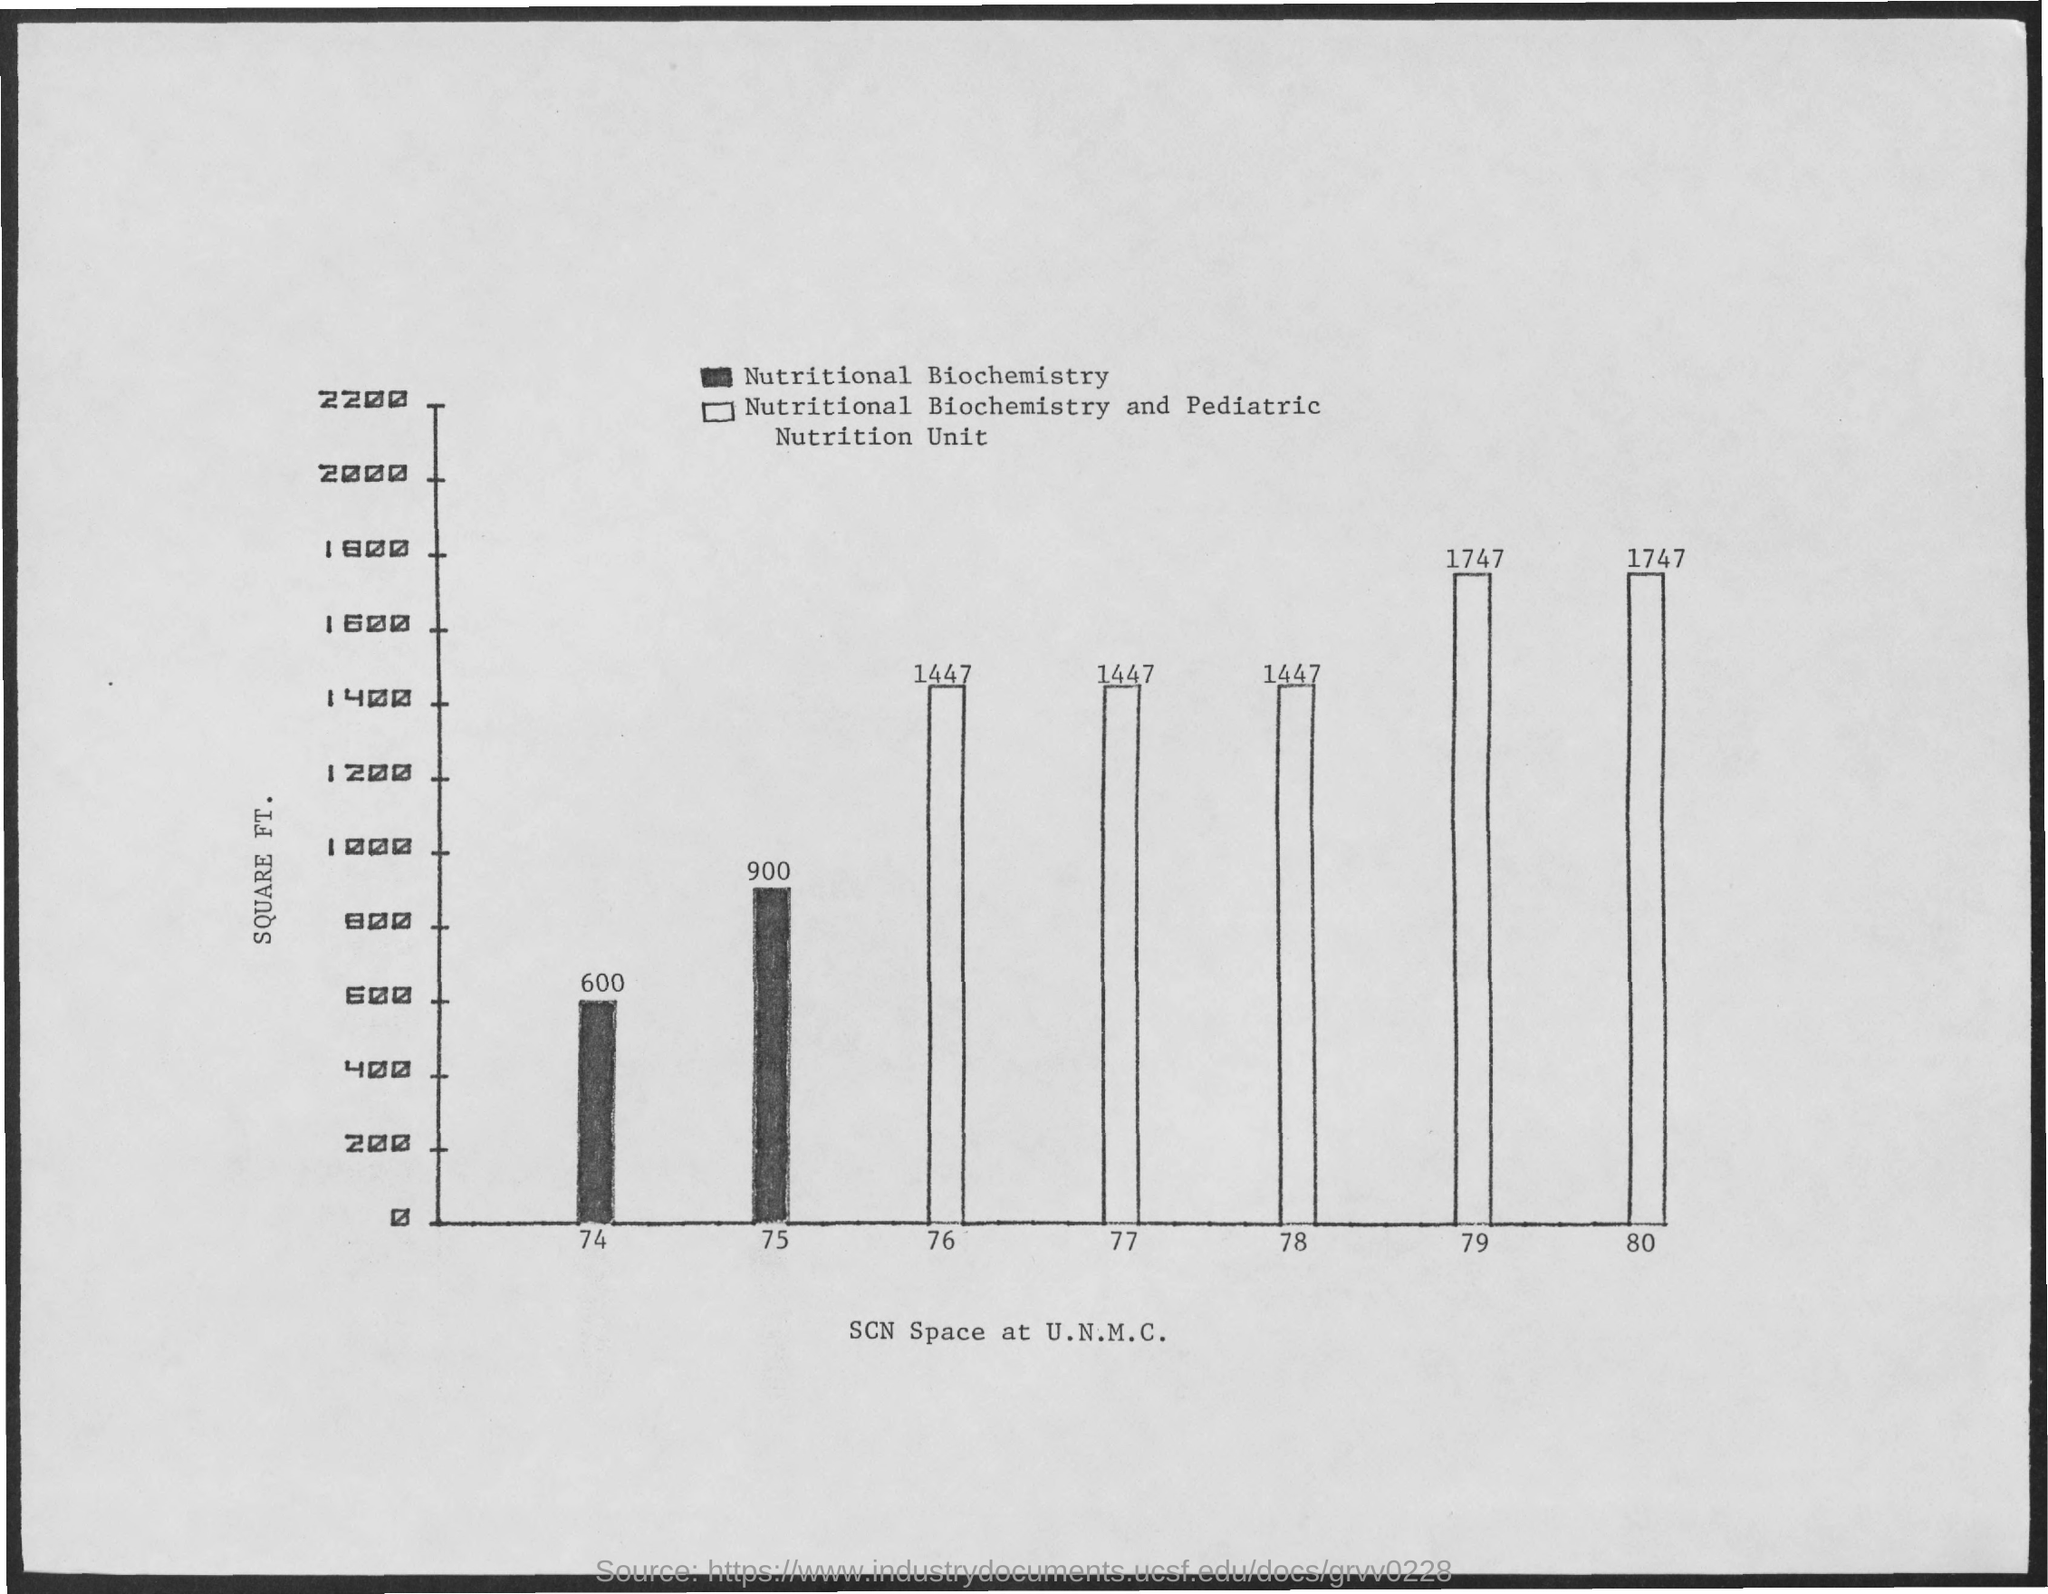What is the SCN Space at U.N.M.C in 74?
Provide a short and direct response. 600. What is the SCN Space at U.N.M.C in 75?
Your answer should be very brief. 900 SQUARE FT. What is the SCN Space at U.N.M.C in 76?
Keep it short and to the point. 1447 SQUARE FT. What is the SCN Space at U.N.M.C in 77?
Provide a succinct answer. 1447 SQUARE FT. What is the SCN Space at U.N.M.C in 78?
Provide a succinct answer. 1447. What is the SCN Space at U.N.M.C in 79?
Offer a terse response. 1747 SQUARE FT. What is the SCN Space at U.N.M.C in 80?
Ensure brevity in your answer.  1747. In 74 and 75 what was the SCN Space at U.N.M.C used for?
Your answer should be compact. Nutritional Biochemistry. Between 76 and 80 what was the SCN Space at U.N.M.C used for?
Provide a succinct answer. Nutritional Biochemistry and Pediatric Nutrition Unit. What is the Y axis for the graph?
Keep it short and to the point. SQUARE FT. 